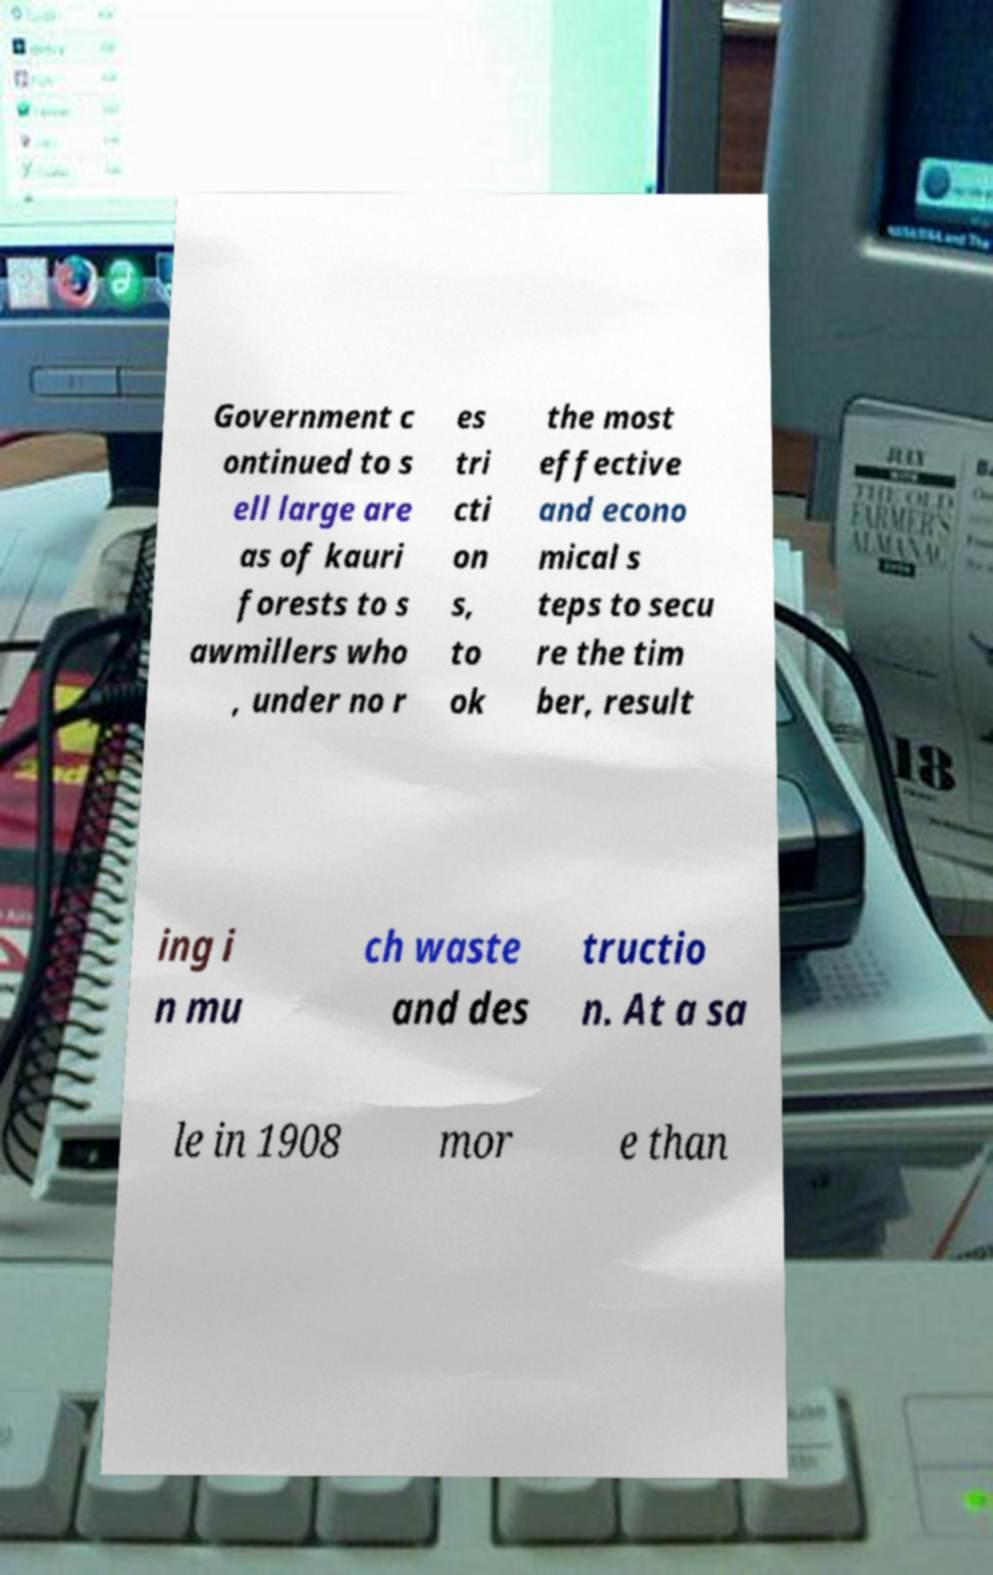Can you read and provide the text displayed in the image?This photo seems to have some interesting text. Can you extract and type it out for me? Government c ontinued to s ell large are as of kauri forests to s awmillers who , under no r es tri cti on s, to ok the most effective and econo mical s teps to secu re the tim ber, result ing i n mu ch waste and des tructio n. At a sa le in 1908 mor e than 